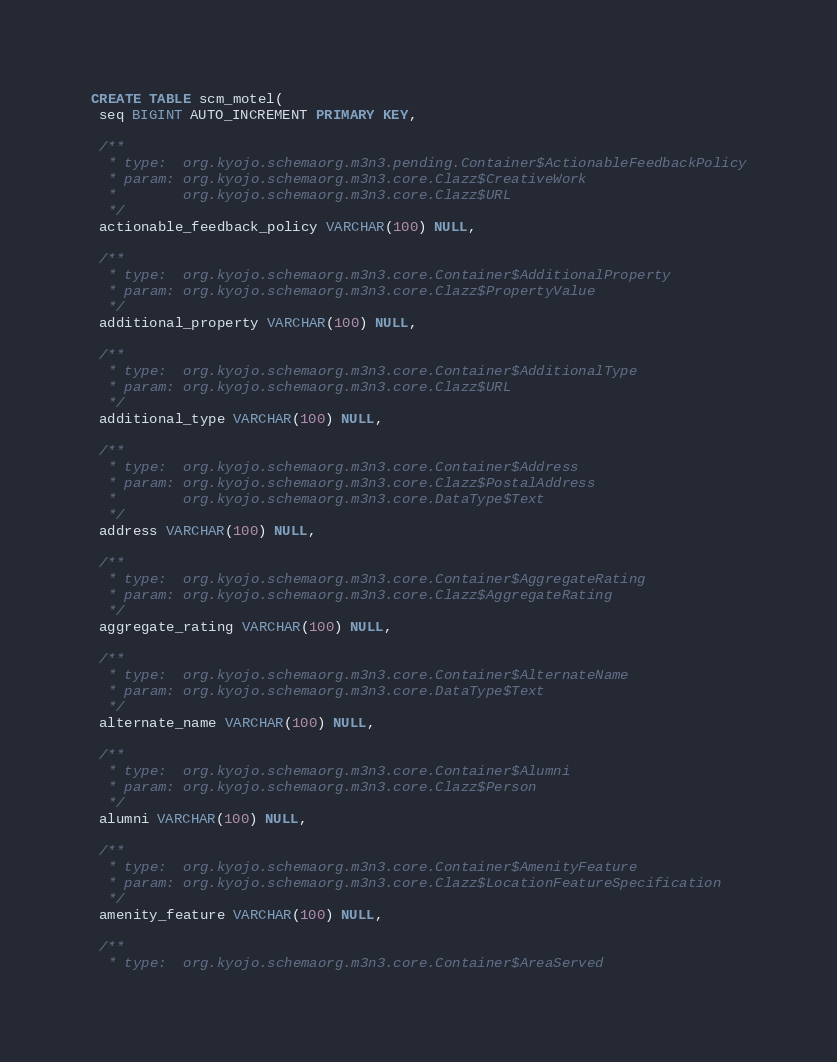Convert code to text. <code><loc_0><loc_0><loc_500><loc_500><_SQL_>CREATE TABLE scm_motel(
 seq BIGINT AUTO_INCREMENT PRIMARY KEY,

 /**
  * type:  org.kyojo.schemaorg.m3n3.pending.Container$ActionableFeedbackPolicy
  * param: org.kyojo.schemaorg.m3n3.core.Clazz$CreativeWork
  *        org.kyojo.schemaorg.m3n3.core.Clazz$URL
  */
 actionable_feedback_policy VARCHAR(100) NULL,

 /**
  * type:  org.kyojo.schemaorg.m3n3.core.Container$AdditionalProperty
  * param: org.kyojo.schemaorg.m3n3.core.Clazz$PropertyValue
  */
 additional_property VARCHAR(100) NULL,

 /**
  * type:  org.kyojo.schemaorg.m3n3.core.Container$AdditionalType
  * param: org.kyojo.schemaorg.m3n3.core.Clazz$URL
  */
 additional_type VARCHAR(100) NULL,

 /**
  * type:  org.kyojo.schemaorg.m3n3.core.Container$Address
  * param: org.kyojo.schemaorg.m3n3.core.Clazz$PostalAddress
  *        org.kyojo.schemaorg.m3n3.core.DataType$Text
  */
 address VARCHAR(100) NULL,

 /**
  * type:  org.kyojo.schemaorg.m3n3.core.Container$AggregateRating
  * param: org.kyojo.schemaorg.m3n3.core.Clazz$AggregateRating
  */
 aggregate_rating VARCHAR(100) NULL,

 /**
  * type:  org.kyojo.schemaorg.m3n3.core.Container$AlternateName
  * param: org.kyojo.schemaorg.m3n3.core.DataType$Text
  */
 alternate_name VARCHAR(100) NULL,

 /**
  * type:  org.kyojo.schemaorg.m3n3.core.Container$Alumni
  * param: org.kyojo.schemaorg.m3n3.core.Clazz$Person
  */
 alumni VARCHAR(100) NULL,

 /**
  * type:  org.kyojo.schemaorg.m3n3.core.Container$AmenityFeature
  * param: org.kyojo.schemaorg.m3n3.core.Clazz$LocationFeatureSpecification
  */
 amenity_feature VARCHAR(100) NULL,

 /**
  * type:  org.kyojo.schemaorg.m3n3.core.Container$AreaServed</code> 